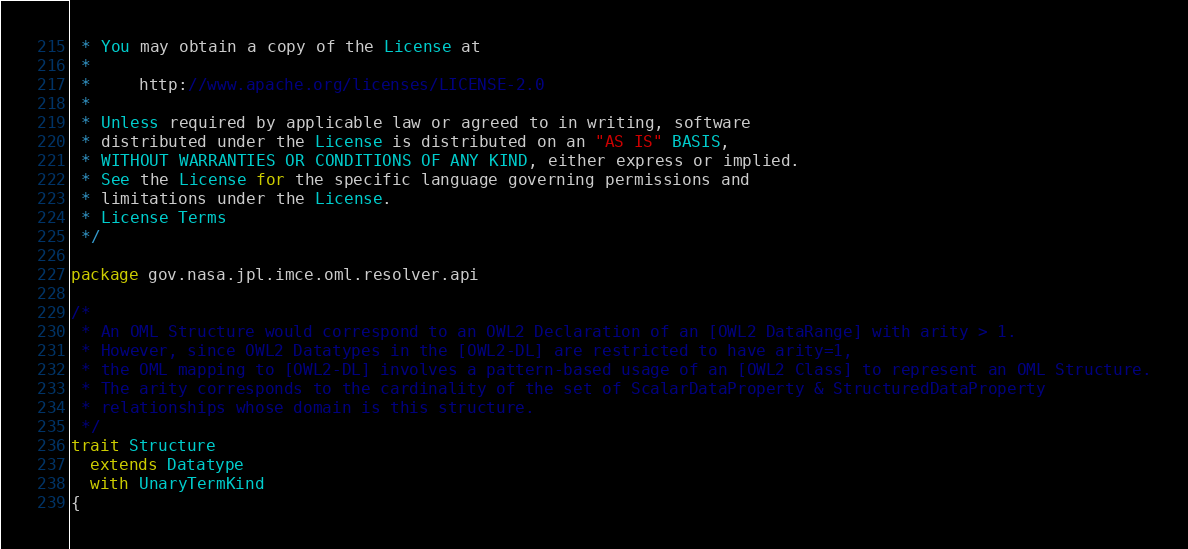<code> <loc_0><loc_0><loc_500><loc_500><_Scala_> * You may obtain a copy of the License at
 *
 *     http://www.apache.org/licenses/LICENSE-2.0
 *
 * Unless required by applicable law or agreed to in writing, software
 * distributed under the License is distributed on an "AS IS" BASIS,
 * WITHOUT WARRANTIES OR CONDITIONS OF ANY KIND, either express or implied.
 * See the License for the specific language governing permissions and
 * limitations under the License.
 * License Terms
 */

package gov.nasa.jpl.imce.oml.resolver.api

/*
 * An OML Structure would correspond to an OWL2 Declaration of an [OWL2 DataRange] with arity > 1.
 * However, since OWL2 Datatypes in the [OWL2-DL] are restricted to have arity=1,
 * the OML mapping to [OWL2-DL] involves a pattern-based usage of an [OWL2 Class] to represent an OML Structure.
 * The arity corresponds to the cardinality of the set of ScalarDataProperty & StructuredDataProperty
 * relationships whose domain is this structure.
 */
trait Structure
  extends Datatype
  with UnaryTermKind
{</code> 